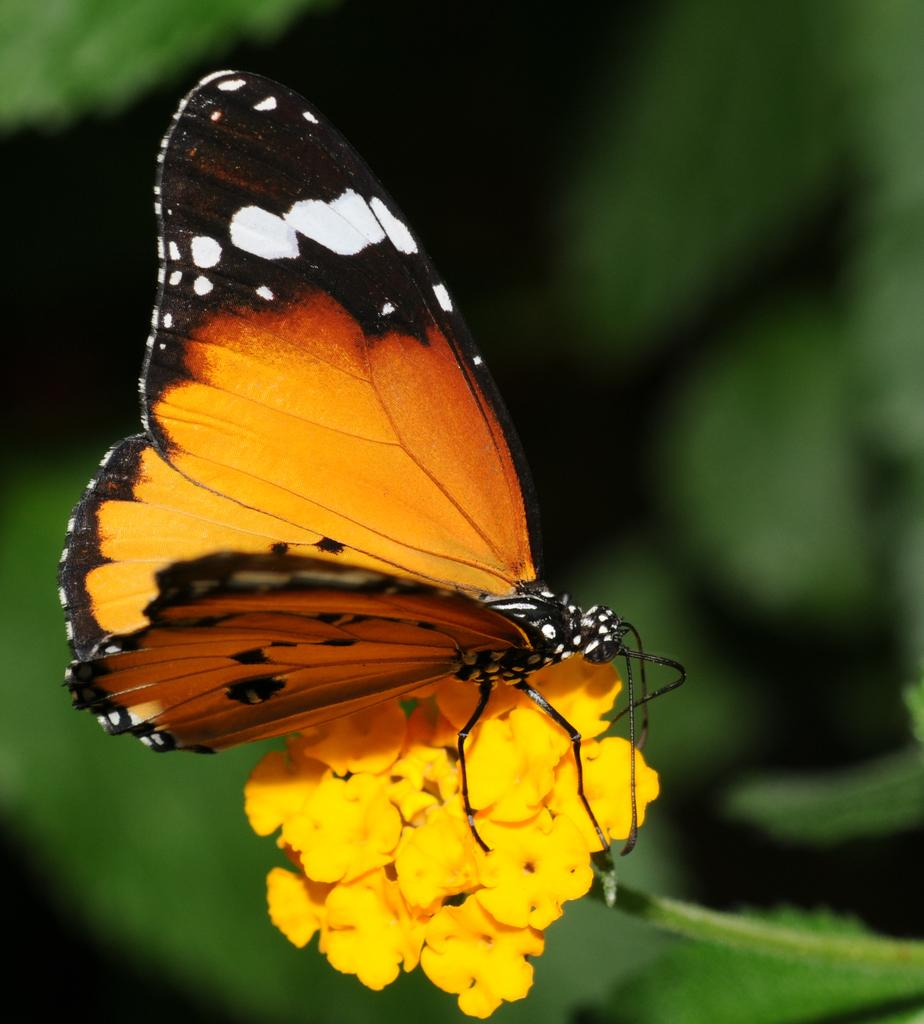What is the main subject of the image? There is a butterfly in the image. Where is the butterfly located in the image? The butterfly is on the flowers. What type of war is depicted in the image involving the butterfly and a group of sacks? There is no war or sacks present in the image; it features a butterfly on flowers. 